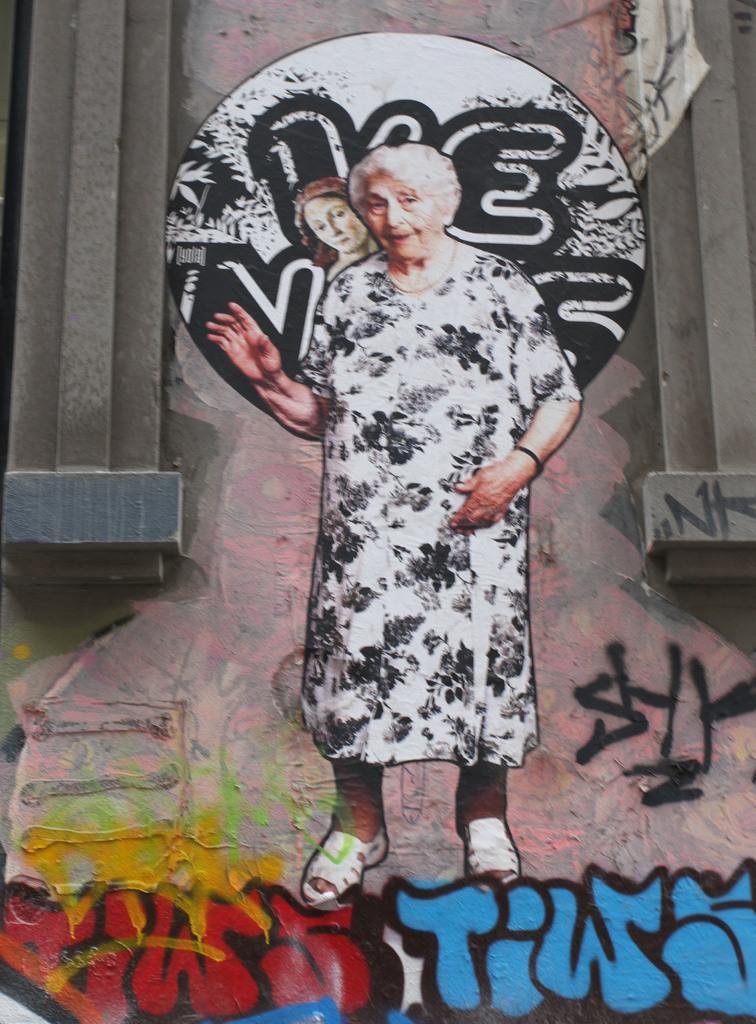How would you summarize this image in a sentence or two? In this picture we can see the graffiti image of an old woman and other drawings. We can also see pillars on either side of the graffiti wall. 